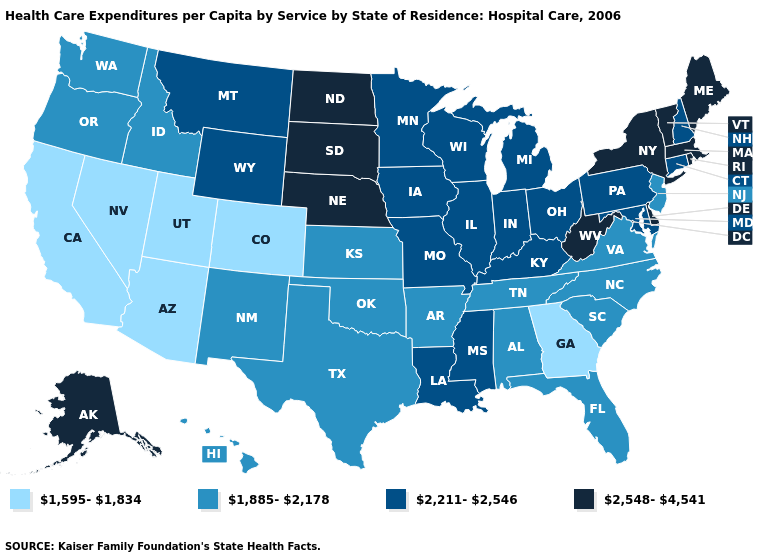What is the lowest value in states that border Colorado?
Concise answer only. 1,595-1,834. What is the lowest value in the MidWest?
Answer briefly. 1,885-2,178. Does Utah have the lowest value in the West?
Concise answer only. Yes. Name the states that have a value in the range 1,885-2,178?
Short answer required. Alabama, Arkansas, Florida, Hawaii, Idaho, Kansas, New Jersey, New Mexico, North Carolina, Oklahoma, Oregon, South Carolina, Tennessee, Texas, Virginia, Washington. Does Delaware have the same value as Florida?
Concise answer only. No. What is the value of Delaware?
Concise answer only. 2,548-4,541. Name the states that have a value in the range 1,885-2,178?
Give a very brief answer. Alabama, Arkansas, Florida, Hawaii, Idaho, Kansas, New Jersey, New Mexico, North Carolina, Oklahoma, Oregon, South Carolina, Tennessee, Texas, Virginia, Washington. What is the value of Oregon?
Quick response, please. 1,885-2,178. What is the value of Minnesota?
Concise answer only. 2,211-2,546. Name the states that have a value in the range 1,885-2,178?
Be succinct. Alabama, Arkansas, Florida, Hawaii, Idaho, Kansas, New Jersey, New Mexico, North Carolina, Oklahoma, Oregon, South Carolina, Tennessee, Texas, Virginia, Washington. What is the value of Louisiana?
Quick response, please. 2,211-2,546. Does Nevada have the lowest value in the USA?
Write a very short answer. Yes. How many symbols are there in the legend?
Quick response, please. 4. Name the states that have a value in the range 1,885-2,178?
Concise answer only. Alabama, Arkansas, Florida, Hawaii, Idaho, Kansas, New Jersey, New Mexico, North Carolina, Oklahoma, Oregon, South Carolina, Tennessee, Texas, Virginia, Washington. Does Wyoming have the highest value in the USA?
Keep it brief. No. 